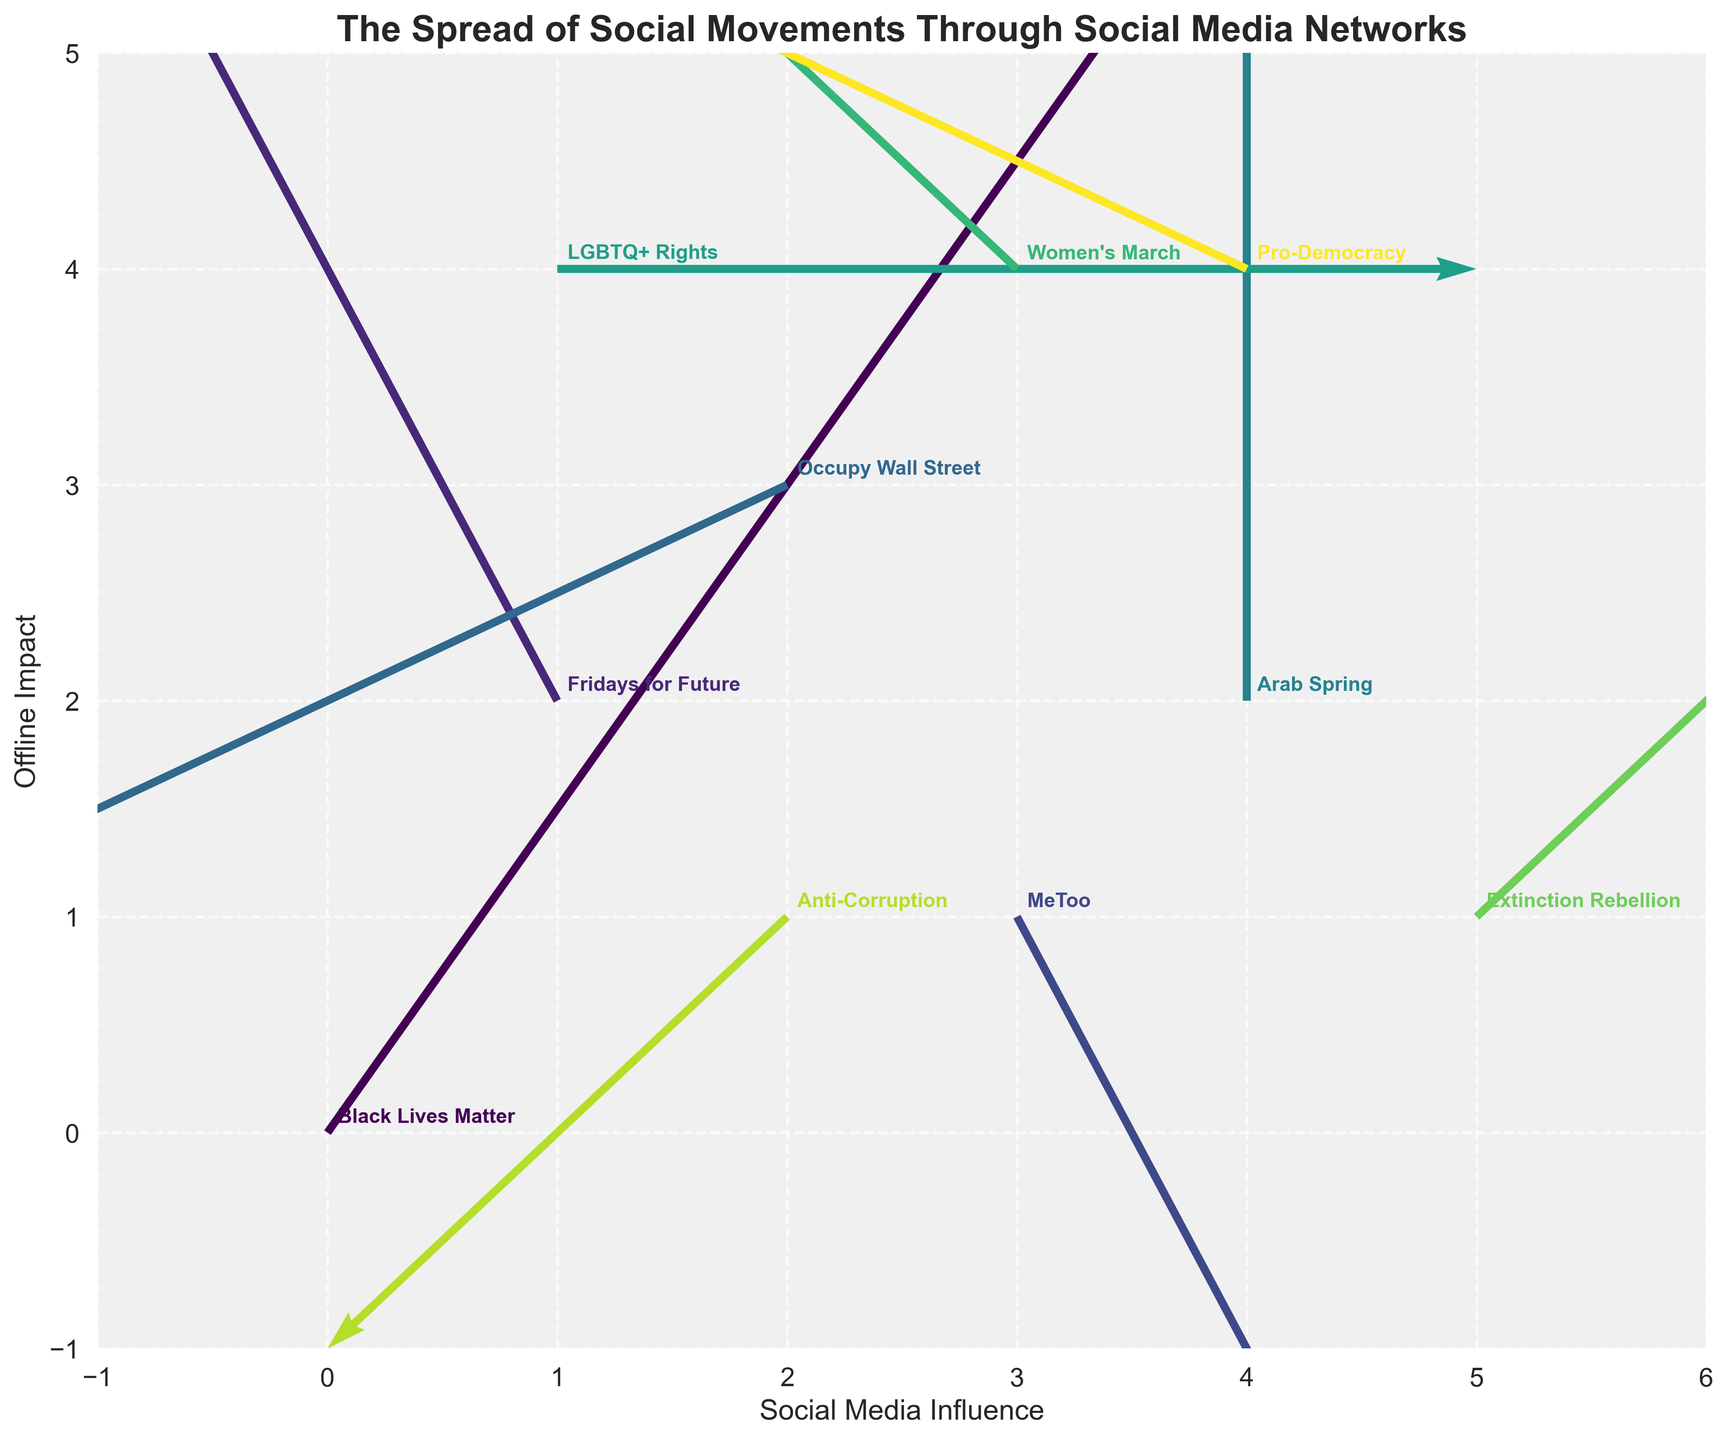What does the title of the figure indicate? The title of the figure is "The Spread of Social Movements Through Social Media Networks". This indicates that the figure visualizes how various social movements spread and influence through social media.
Answer: The Spread of Social Movements Through Social Media Networks What movement has the highest value for "Social Media Influence"? The "Social Media Influence" is represented by the X-coordinate. The movement with the highest X-coordinate is "Extinction Rebellion" at X = 5.
Answer: Extinction Rebellion Which movement has the vector with the greatest magnitude, and what are the X and Y components of this vector? The magnitude of a vector can be calculated using the formula √(U² + V²). When you calculate this for each vector, "Black Lives Matter" with U = 2 and V = 3 has the greatest magnitude. Calculation: √(2² + 3²) = √(4 + 9) = √13 ≈ 3.61.
Answer: Black Lives Matter, U = 2, V = 3 How many social movements are displayed in the figure? To determine the number of social movements, we can count the unique labels associated with each quiver (arrow) in the plot. There are 10 labels for 10 social movements in the figure.
Answer: 10 Which movement has the vector with the smallest magnitude? The magnitude of a vector (U, V) is calculated as √(U² + V²). The movement "LGBTQ+ Rights" has the components U = 2 and V = 0, resulting in the smallest magnitude vector as √(2² + 0²) = 2.
Answer: LGBTQ+ Rights What are the X and Y components of the vectors representing the "Pro-Democracy" and "Arab Spring" movements? For the "Pro-Democracy" movement, the components are U = -2 and V = 1. For the "Arab Spring" movement, the components are U = 0 and V = 2.
Answer: Pro-Democracy: U = -2, V = 1; Arab Spring: U = 0, V = 2 Which movement has the quiver pointing directly upward, and where is it located? A quiver pointing directly upward will have U = 0 and V > 0. The "Arab Spring" movement satisfies this with U = 0, V = 2 and is located at (X, Y) = (4, 2).
Answer: Arab Spring, (4, 2) Compare the direction and magnitude of vectors for "MeToo" and "Women's March". Which one points more northward? The "MeToo" vector points downward (1, -2) with a magnitude of √(1² + (-2)²) = √5. The "Women's March" vector points upward but with northward component only 1, so it points more northward despite smaller magnitude.
Answer: Women's March 